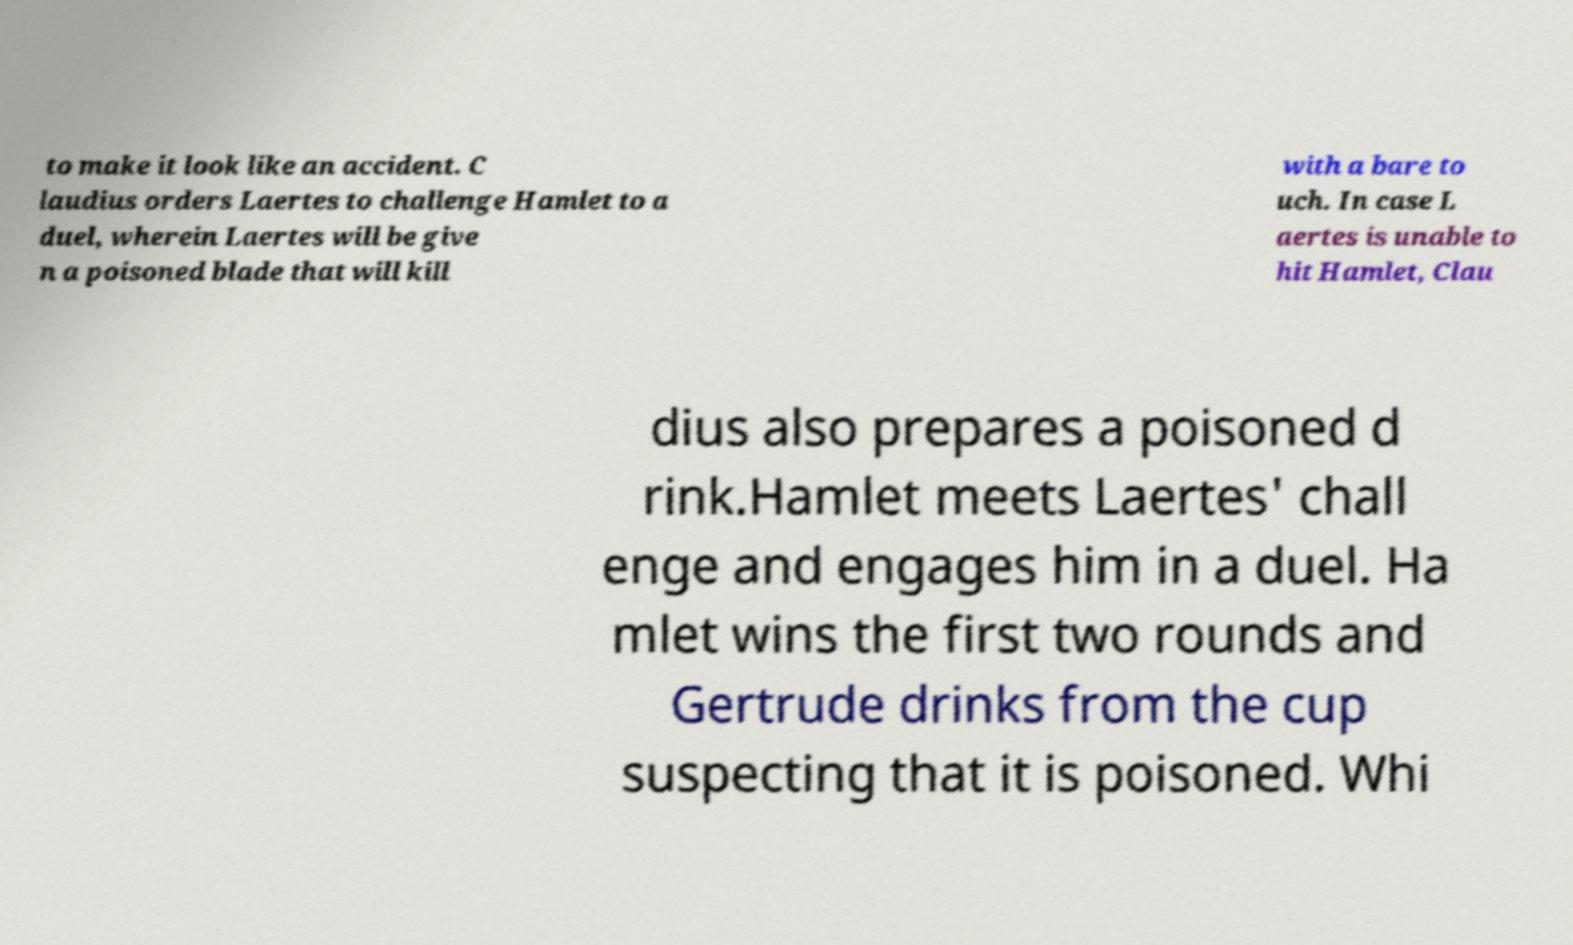There's text embedded in this image that I need extracted. Can you transcribe it verbatim? to make it look like an accident. C laudius orders Laertes to challenge Hamlet to a duel, wherein Laertes will be give n a poisoned blade that will kill with a bare to uch. In case L aertes is unable to hit Hamlet, Clau dius also prepares a poisoned d rink.Hamlet meets Laertes' chall enge and engages him in a duel. Ha mlet wins the first two rounds and Gertrude drinks from the cup suspecting that it is poisoned. Whi 